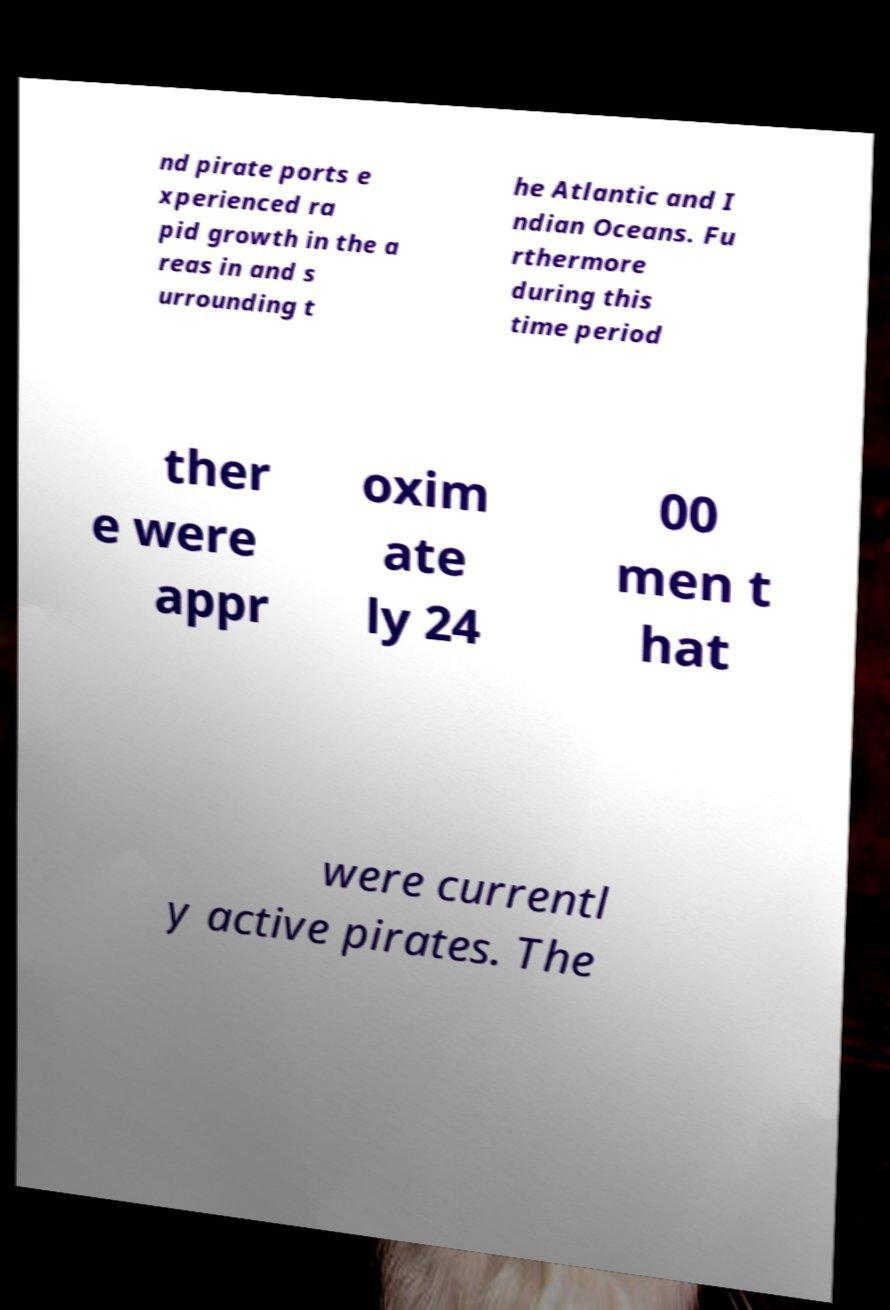Could you assist in decoding the text presented in this image and type it out clearly? nd pirate ports e xperienced ra pid growth in the a reas in and s urrounding t he Atlantic and I ndian Oceans. Fu rthermore during this time period ther e were appr oxim ate ly 24 00 men t hat were currentl y active pirates. The 